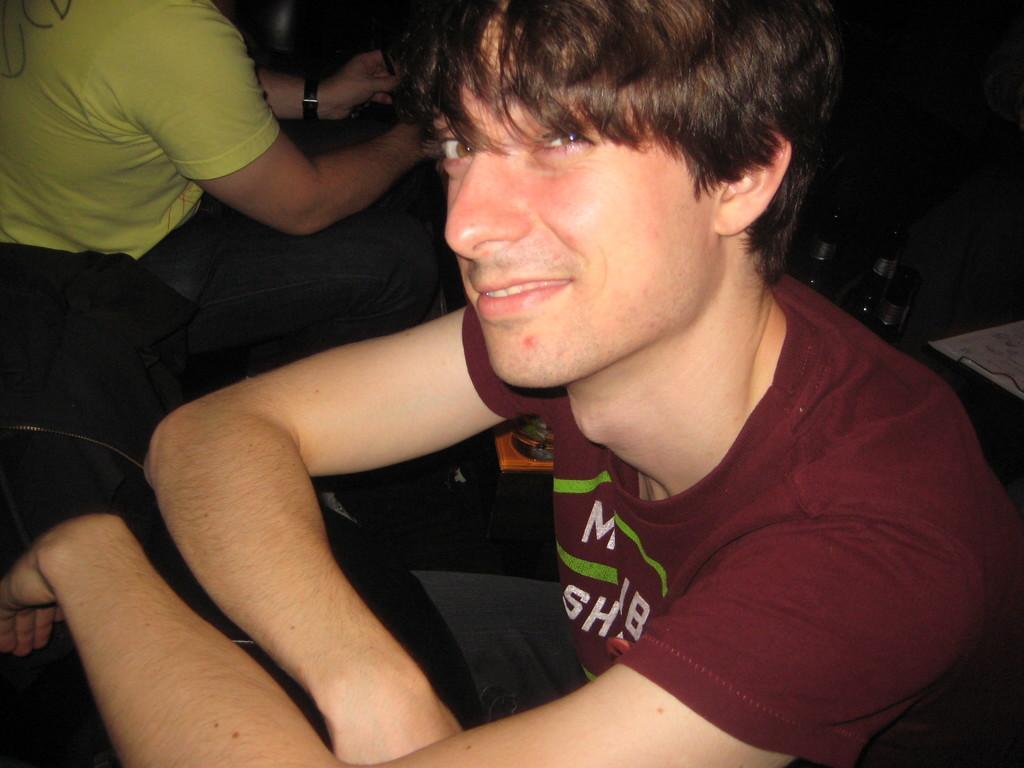In one or two sentences, can you explain what this image depicts? In the picture I can see a man wearing a T-shirt and there is a smile on his face. It is looking like a table on the bottom left side of the picture. I can see the glass bottles on the right side. I can another person on the top left side of the picture. 